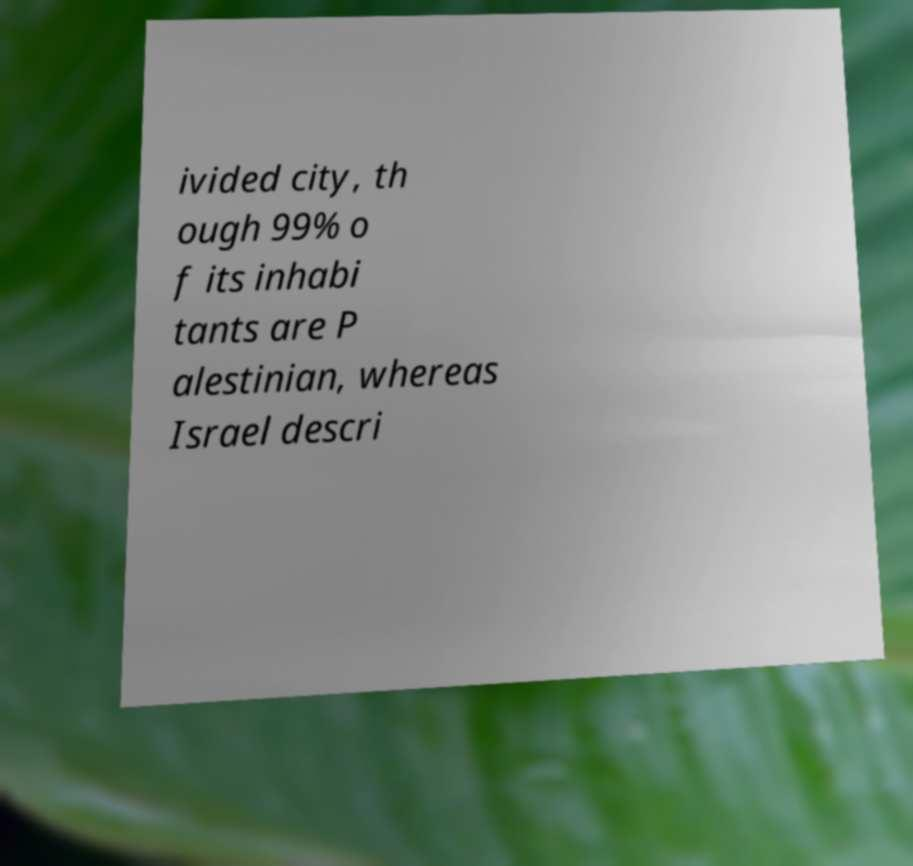There's text embedded in this image that I need extracted. Can you transcribe it verbatim? ivided city, th ough 99% o f its inhabi tants are P alestinian, whereas Israel descri 